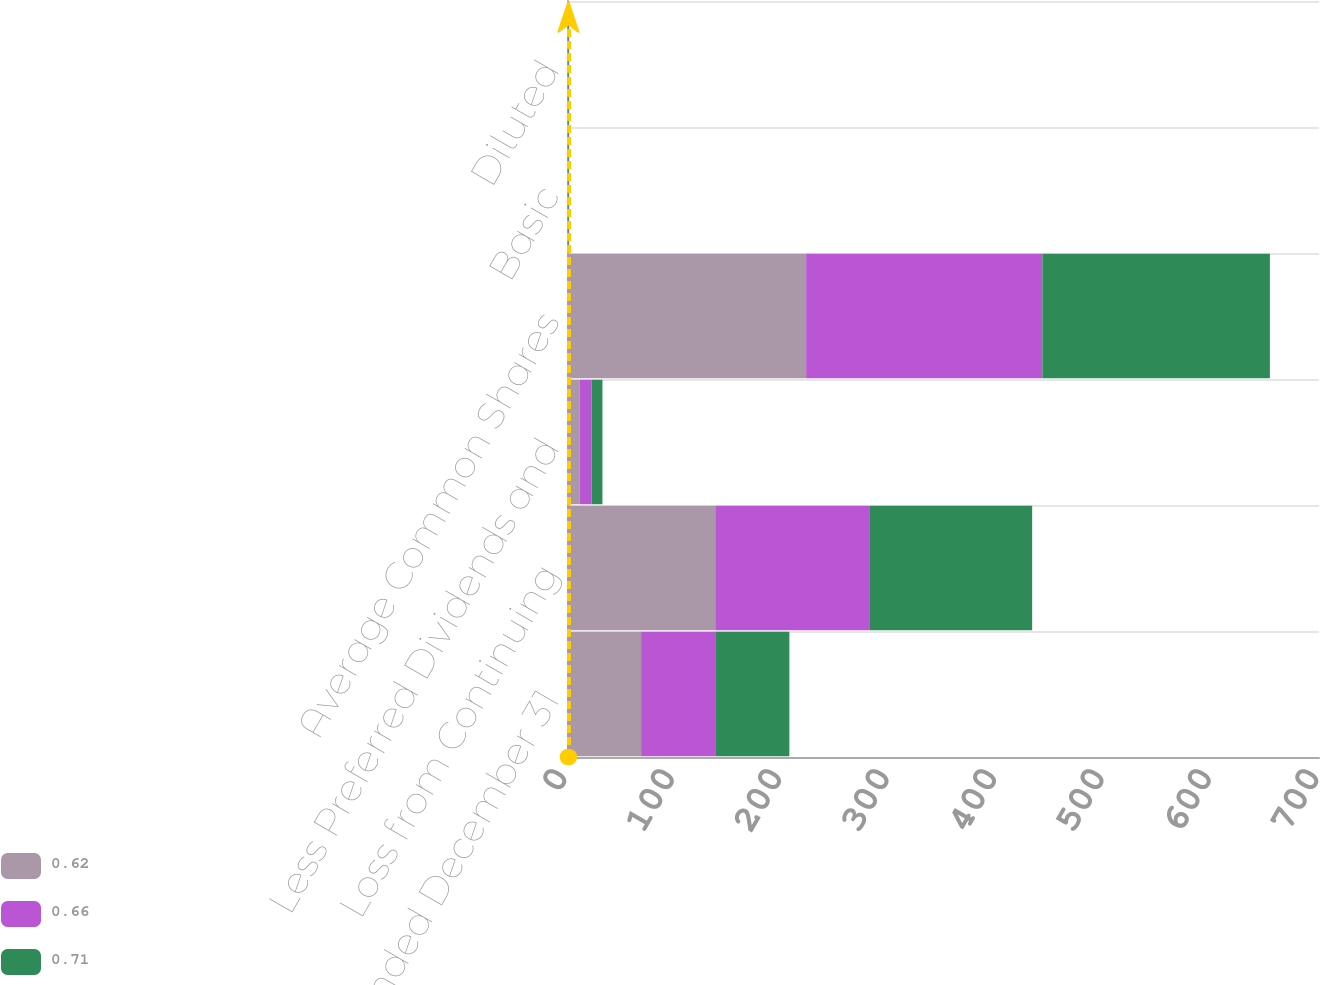Convert chart to OTSL. <chart><loc_0><loc_0><loc_500><loc_500><stacked_bar_chart><ecel><fcel>Years Ended December 31<fcel>Loss from Continuing<fcel>Less Preferred Dividends and<fcel>Average Common Shares<fcel>Basic<fcel>Diluted<nl><fcel>0.62<fcel>69<fcel>138<fcel>12<fcel>222.6<fcel>0.62<fcel>0.62<nl><fcel>0.66<fcel>69<fcel>144<fcel>11<fcel>219.9<fcel>0.66<fcel>0.66<nl><fcel>0.71<fcel>69<fcel>151<fcel>10<fcel>211.8<fcel>0.71<fcel>0.71<nl></chart> 